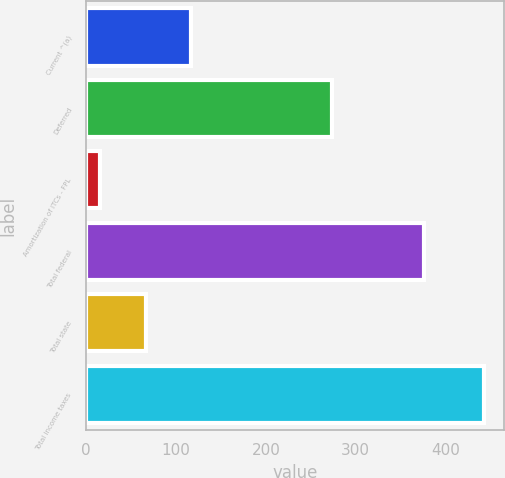<chart> <loc_0><loc_0><loc_500><loc_500><bar_chart><fcel>Current ^(a)<fcel>Deferred<fcel>Amortization of ITCs - FPL<fcel>Total federal<fcel>Total state<fcel>Total income taxes<nl><fcel>117<fcel>274<fcel>15<fcel>376<fcel>67<fcel>443<nl></chart> 